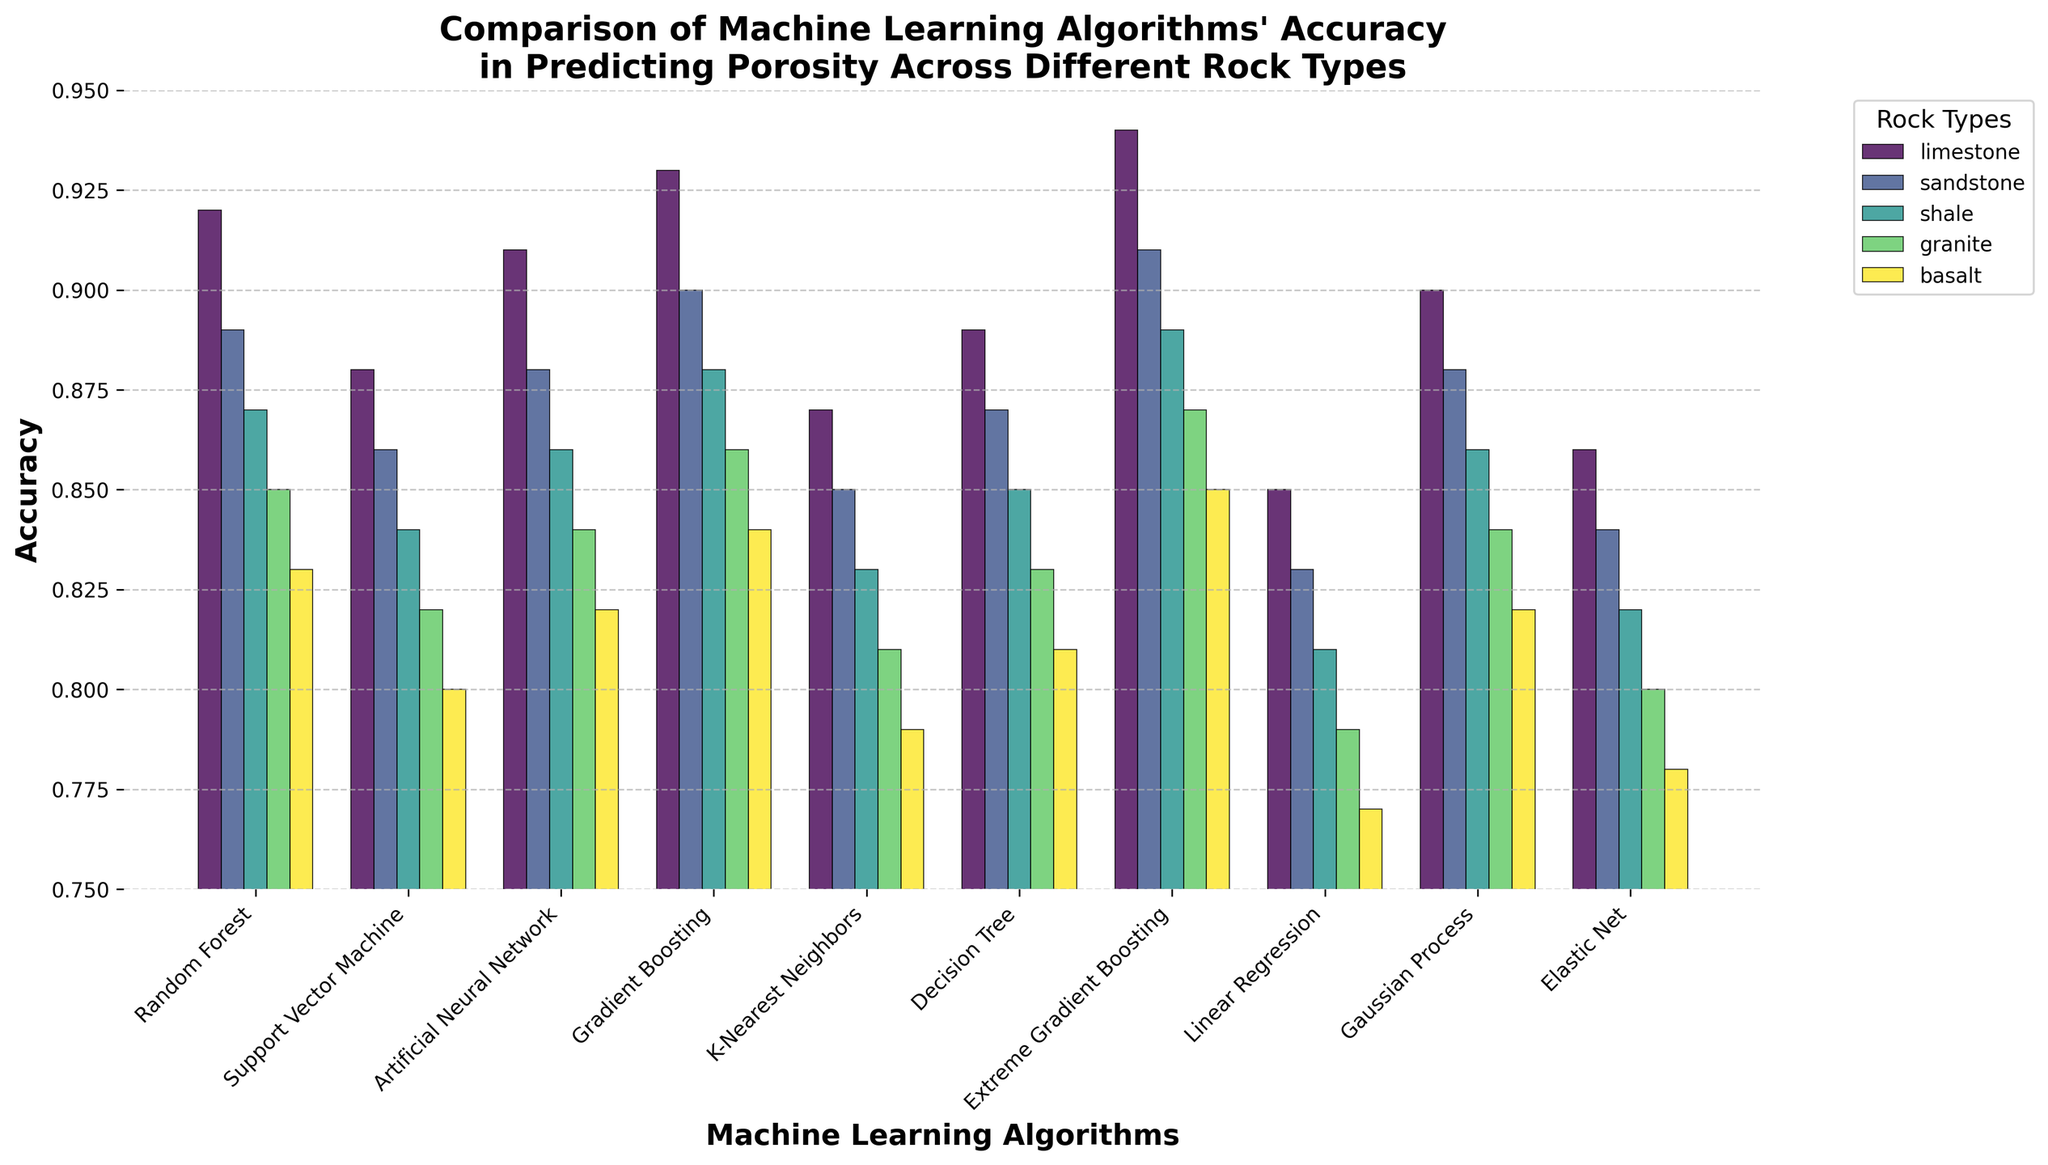Which machine learning algorithm has the highest accuracy for predicting porosity in limestone? Look for the tallest bar within the 'Limestone' group. The algorithm with the tallest bar is Extreme Gradient Boosting.
Answer: Extreme Gradient Boosting Which rock type has the lowest overall accuracy among the algorithms? Compare the heights of all the bars across different rock types. Basalt consistently has the shortest bars, indicating the lowest accuracies.
Answer: Basalt What is the average accuracy of Random Forest across all rock types? Sum the accuracies of Random Forest for all rock types: (0.92 + 0.89 + 0.87 + 0.85 + 0.83) = 4.36. Then, divide by 5 to find the average: 4.36 / 5 = 0.872.
Answer: 0.872 Which two algorithms have equal accuracy for shale? Find the accuracies for shale and see if any two are the same. Artificial Neural Network and Gaussian Process both have an accuracy of 0.86 for shale.
Answer: Artificial Neural Network, Gaussian Process Which algorithm has the largest difference in accuracy between limestone and basalt? Calculate the differences for each algorithm: 
Random Forest (0.92 - 0.83 = 0.09),
Support Vector Machine (0.88 - 0.80 = 0.08),
Artificial Neural Network (0.91 - 0.82 = 0.09),
Gradient Boosting (0.93 - 0.84 = 0.09),
K-Nearest Neighbors (0.87 - 0.79 = 0.08),
Decision Tree (0.89 - 0.81 = 0.08),
Extreme Gradient Boosting (0.94 - 0.85 = 0.09),
Linear Regression (0.85 - 0.77 = 0.08),
Gaussian Process (0.90 - 0.82 = 0.08),
Elastic Net (0.86 - 0.78 = 0.08).
All aforementioned algorithms except for Random Forest, Support Vector Machine, K-Nearest Neighbors, Decision Tree, Gaussian Process and Elastic Net exhibit the largest difference, which is 0.09.
Answer: Random Forest, Artificial Neural Network, Gradient Boosting, Extreme Gradient Boosting What is the median accuracy of Support Vector Machine across all rock types? Sort the accuracies of Support Vector Machine: [0.80, 0.82, 0.84, 0.86, 0.88]. The median is the middle value, which is 0.84.
Answer: 0.84 How many algorithms achieve an accuracy of 0.90 or higher for limestone? Check the accuracy values for limestone: Random Forest (0.92), Support Vector Machine (0.88), Artificial Neural Network (0.91), Gradient Boosting (0.93), K-Nearest Neighbors (0.87), Decision Tree (0.89), Extreme Gradient Boosting (0.94), Linear Regression (0.85), Gaussian Process (0.90), Elastic Net (0.86). Only Random Forest, Artificial Neural Network, Gradient Boosting, Extreme Gradient Boosting, and Gaussian Process meet this criterion, so there are 5.
Answer: 5 